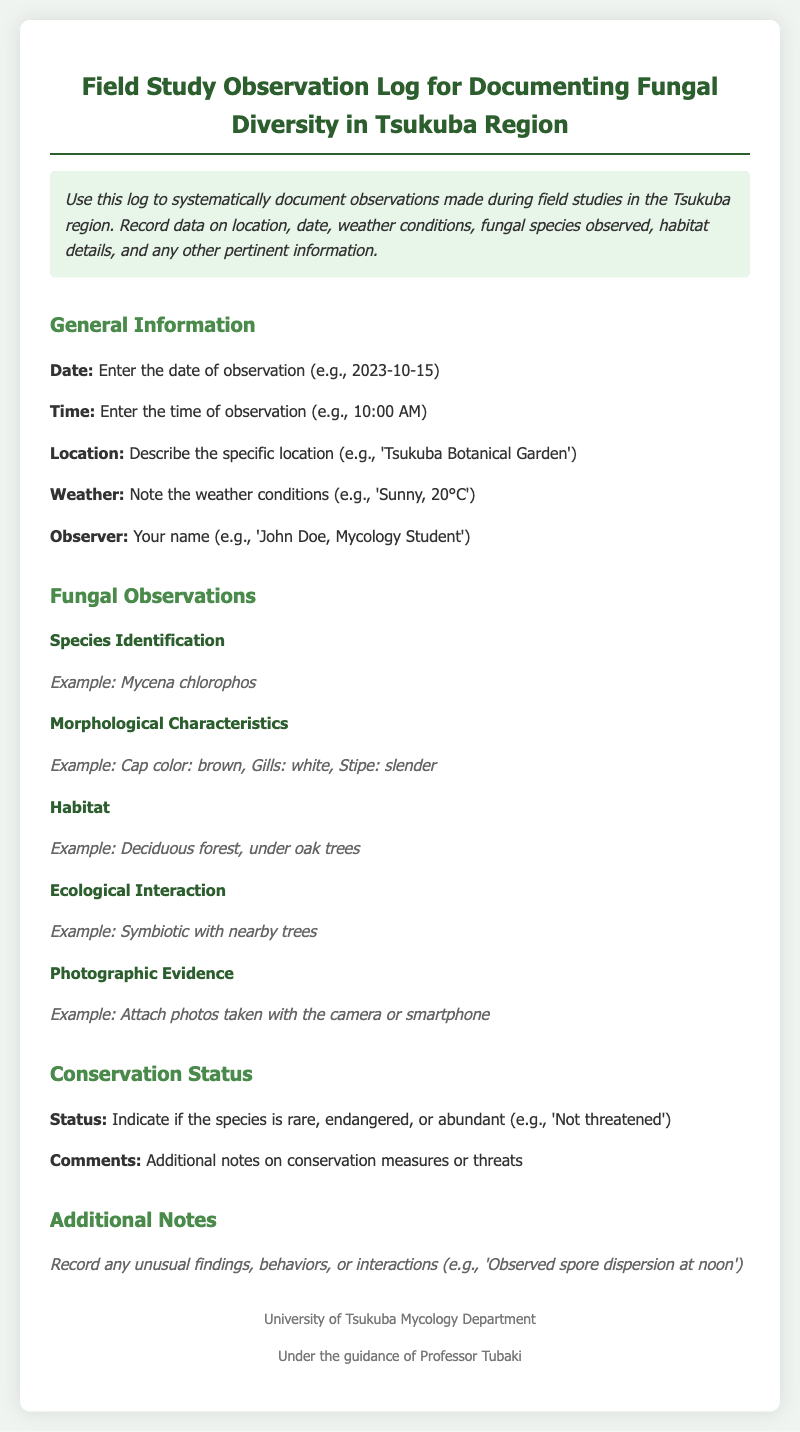What is the title of the manual? The title of the manual is found at the top of the document and indicates its purpose.
Answer: Field Study Observation Log for Documenting Fungal Diversity in Tsukuba Region What should be recorded for the observation date? The document specifies how to format the observation date, which includes the year, month, and day.
Answer: 2023-10-15 What type of characteristics are noted in species identification? The document includes details about specific morphological features that should be observed and described.
Answer: Mycena chlorophos What habitat should be recorded for fungal observations? The example provided in the document illustrates what type of habitat description is expected.
Answer: Deciduous forest, under oak trees How should the conservation status be indicated? The document suggests a method for categorizing the conservation status of the observed species.
Answer: Not threatened Why is the observer's name important? The document mentions that the observer's name is required in the log for accountability and record-keeping purposes.
Answer: To identify the person conducting the observation What kind of photographic evidence is mentioned? The document specifies that photographic evidence should be attached to support the observations made in the log.
Answer: Attach photos taken with the camera or smartphone Are there any comments section included? The document provides a section for additional comments that might be relevant to observations made during the study.
Answer: Yes, additional notes on conservation measures or threats What ecological interaction is suggested to be noted? The document describes interactions that can be observed in the ecosystem, which should be recorded in the log.
Answer: Symbiotic with nearby trees 